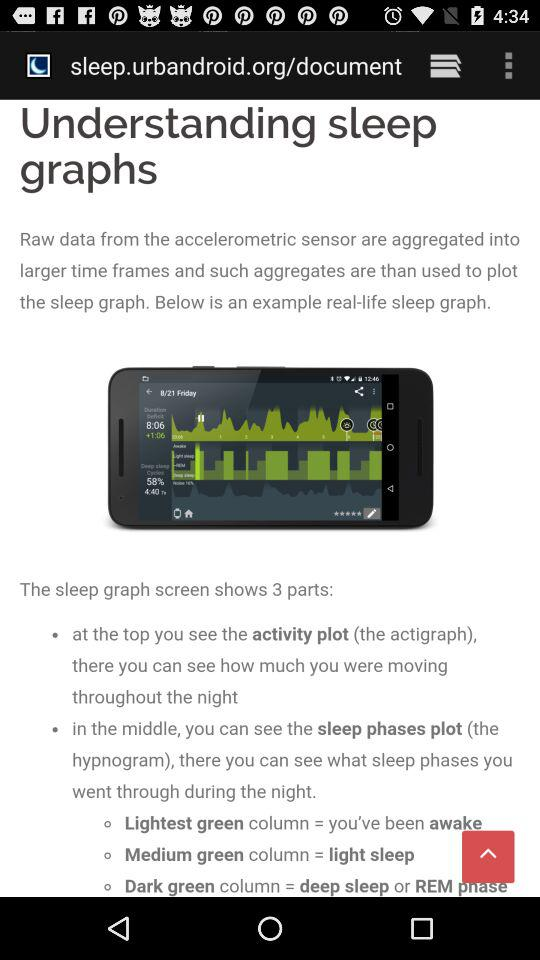How many columns are there in the sleep phases plot?
Answer the question using a single word or phrase. 3 